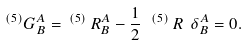<formula> <loc_0><loc_0><loc_500><loc_500>^ { ( 5 ) } G ^ { A } _ { B } = \, ^ { ( 5 ) } \, R ^ { A } _ { B } - \frac { 1 } { 2 } \ \, ^ { ( 5 ) } \, R \ \delta ^ { A } _ { B } = 0 .</formula> 